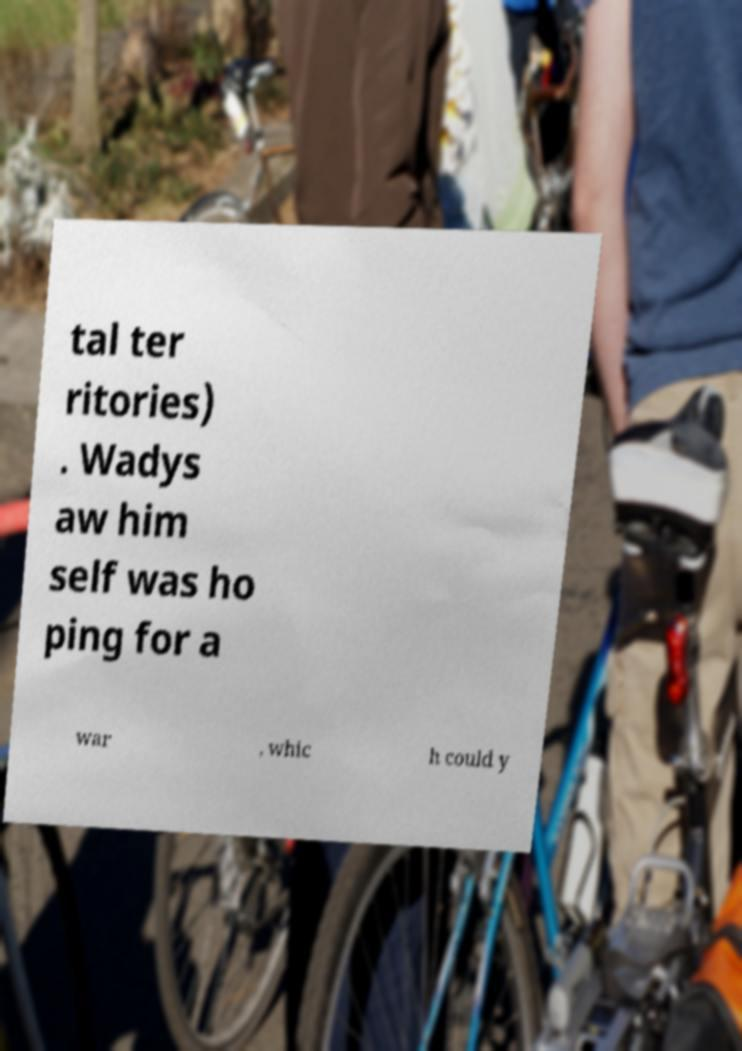Please read and relay the text visible in this image. What does it say? tal ter ritories) . Wadys aw him self was ho ping for a war , whic h could y 